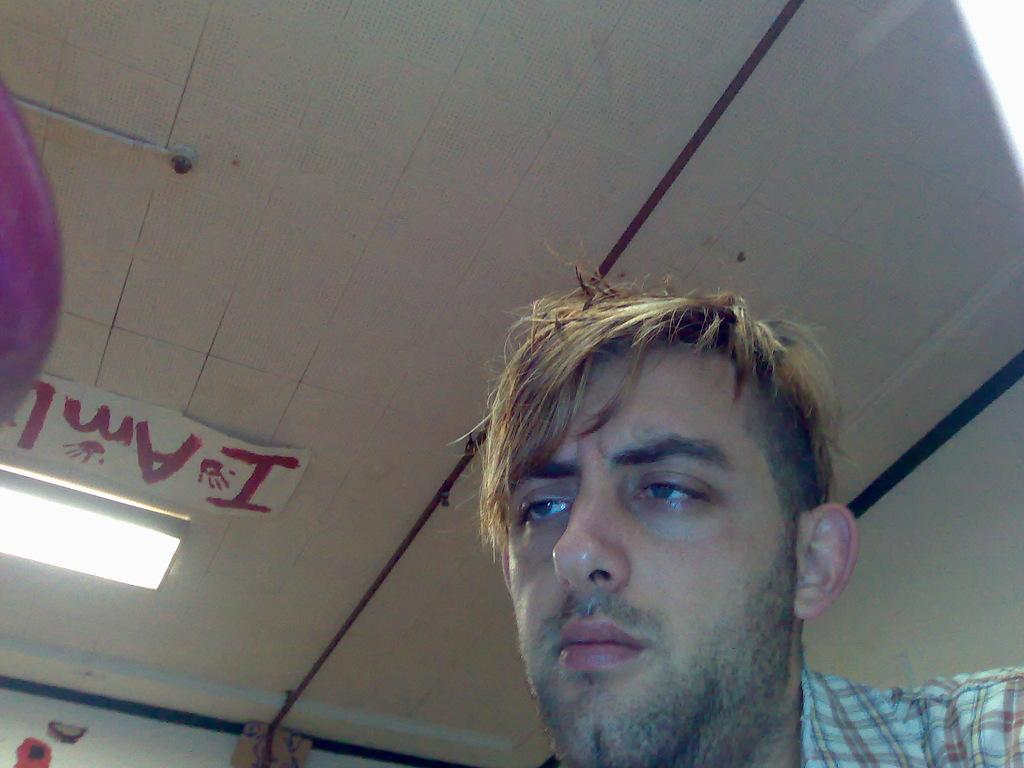Who or what is the main subject in the image? There is a person in the image. Can you describe the person's clothing? The person is wearing a white and brown color shirt. What can be seen in the background of the image? There is light in the background of the image, and the wall is white. How does the person adjust their stomach in the image? There is no indication in the image that the person is adjusting their stomach. 